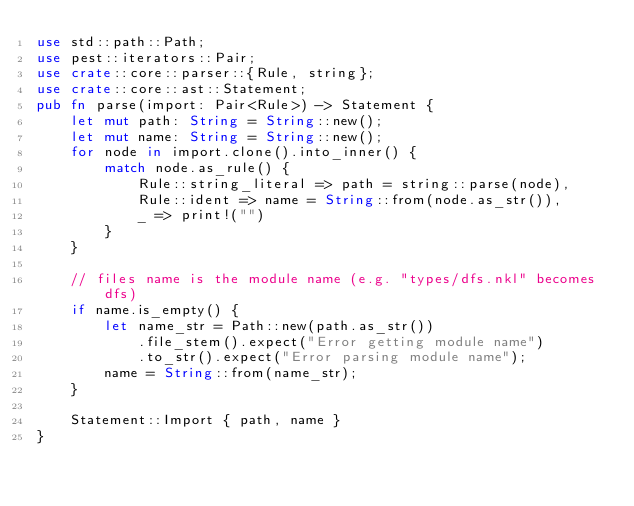<code> <loc_0><loc_0><loc_500><loc_500><_Rust_>use std::path::Path;
use pest::iterators::Pair;
use crate::core::parser::{Rule, string};
use crate::core::ast::Statement;
pub fn parse(import: Pair<Rule>) -> Statement {
    let mut path: String = String::new();
    let mut name: String = String::new();
    for node in import.clone().into_inner() {
        match node.as_rule() {
            Rule::string_literal => path = string::parse(node),
            Rule::ident => name = String::from(node.as_str()),
            _ => print!("")
        }
    }

    // files name is the module name (e.g. "types/dfs.nkl" becomes dfs)
    if name.is_empty() {
        let name_str = Path::new(path.as_str())
            .file_stem().expect("Error getting module name")
            .to_str().expect("Error parsing module name");
        name = String::from(name_str);
    }

    Statement::Import { path, name }
}
</code> 